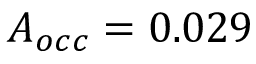Convert formula to latex. <formula><loc_0><loc_0><loc_500><loc_500>A _ { o c c } = 0 . 0 2 9</formula> 